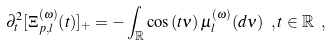<formula> <loc_0><loc_0><loc_500><loc_500>\partial _ { t } ^ { 2 } [ \Xi _ { p , l } ^ { ( \omega ) } ( t ) ] _ { + } = - \int \nolimits _ { \mathbb { R } } \cos \left ( t \nu \right ) \mu _ { l } ^ { ( \omega ) } ( d \nu ) \ , t \in \mathbb { R } \ ,</formula> 